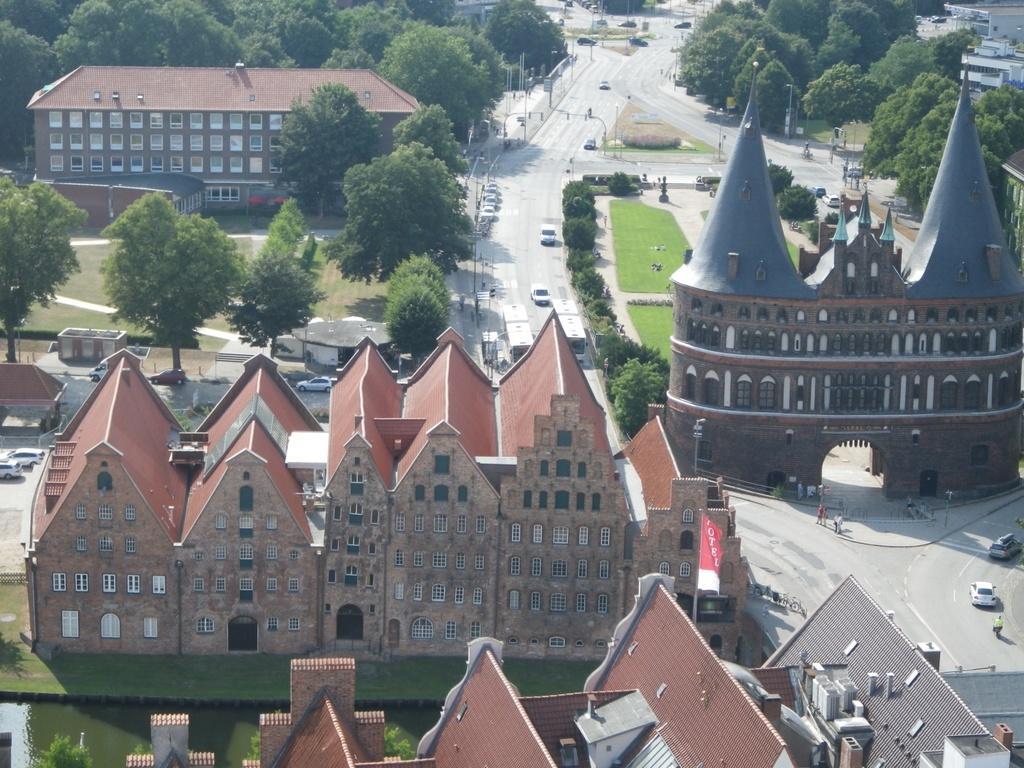Describe this image in one or two sentences. In the picture there is a museum, around that there are many trees, gardens, roads and other huge buildings. 